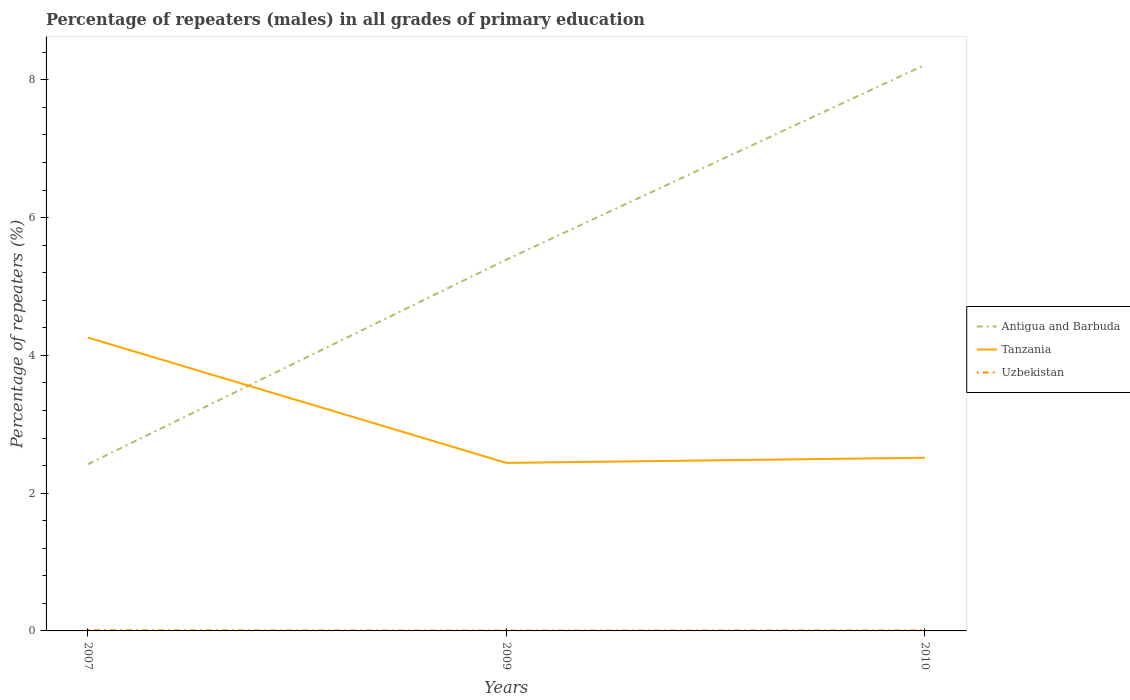Does the line corresponding to Antigua and Barbuda intersect with the line corresponding to Uzbekistan?
Your response must be concise. No. Across all years, what is the maximum percentage of repeaters (males) in Tanzania?
Give a very brief answer. 2.44. In which year was the percentage of repeaters (males) in Tanzania maximum?
Provide a succinct answer. 2009. What is the total percentage of repeaters (males) in Tanzania in the graph?
Offer a very short reply. 1.82. What is the difference between the highest and the second highest percentage of repeaters (males) in Tanzania?
Your response must be concise. 1.82. How many lines are there?
Make the answer very short. 3. How many years are there in the graph?
Your answer should be very brief. 3. What is the difference between two consecutive major ticks on the Y-axis?
Provide a succinct answer. 2. Does the graph contain grids?
Your answer should be very brief. No. How many legend labels are there?
Make the answer very short. 3. What is the title of the graph?
Give a very brief answer. Percentage of repeaters (males) in all grades of primary education. Does "Portugal" appear as one of the legend labels in the graph?
Give a very brief answer. No. What is the label or title of the X-axis?
Make the answer very short. Years. What is the label or title of the Y-axis?
Your answer should be compact. Percentage of repeaters (%). What is the Percentage of repeaters (%) in Antigua and Barbuda in 2007?
Your response must be concise. 2.42. What is the Percentage of repeaters (%) in Tanzania in 2007?
Keep it short and to the point. 4.26. What is the Percentage of repeaters (%) of Uzbekistan in 2007?
Give a very brief answer. 0.01. What is the Percentage of repeaters (%) of Antigua and Barbuda in 2009?
Offer a terse response. 5.39. What is the Percentage of repeaters (%) of Tanzania in 2009?
Make the answer very short. 2.44. What is the Percentage of repeaters (%) in Uzbekistan in 2009?
Ensure brevity in your answer.  0.01. What is the Percentage of repeaters (%) of Antigua and Barbuda in 2010?
Your answer should be very brief. 8.22. What is the Percentage of repeaters (%) in Tanzania in 2010?
Your answer should be compact. 2.51. What is the Percentage of repeaters (%) in Uzbekistan in 2010?
Provide a short and direct response. 0.01. Across all years, what is the maximum Percentage of repeaters (%) in Antigua and Barbuda?
Keep it short and to the point. 8.22. Across all years, what is the maximum Percentage of repeaters (%) of Tanzania?
Provide a succinct answer. 4.26. Across all years, what is the maximum Percentage of repeaters (%) of Uzbekistan?
Keep it short and to the point. 0.01. Across all years, what is the minimum Percentage of repeaters (%) of Antigua and Barbuda?
Make the answer very short. 2.42. Across all years, what is the minimum Percentage of repeaters (%) in Tanzania?
Keep it short and to the point. 2.44. Across all years, what is the minimum Percentage of repeaters (%) in Uzbekistan?
Offer a terse response. 0.01. What is the total Percentage of repeaters (%) in Antigua and Barbuda in the graph?
Ensure brevity in your answer.  16.03. What is the total Percentage of repeaters (%) in Tanzania in the graph?
Your response must be concise. 9.21. What is the total Percentage of repeaters (%) in Uzbekistan in the graph?
Provide a short and direct response. 0.02. What is the difference between the Percentage of repeaters (%) of Antigua and Barbuda in 2007 and that in 2009?
Offer a very short reply. -2.97. What is the difference between the Percentage of repeaters (%) of Tanzania in 2007 and that in 2009?
Your response must be concise. 1.82. What is the difference between the Percentage of repeaters (%) of Uzbekistan in 2007 and that in 2009?
Make the answer very short. 0.01. What is the difference between the Percentage of repeaters (%) of Antigua and Barbuda in 2007 and that in 2010?
Give a very brief answer. -5.8. What is the difference between the Percentage of repeaters (%) in Tanzania in 2007 and that in 2010?
Provide a succinct answer. 1.75. What is the difference between the Percentage of repeaters (%) in Uzbekistan in 2007 and that in 2010?
Your answer should be very brief. 0. What is the difference between the Percentage of repeaters (%) in Antigua and Barbuda in 2009 and that in 2010?
Keep it short and to the point. -2.83. What is the difference between the Percentage of repeaters (%) of Tanzania in 2009 and that in 2010?
Your answer should be very brief. -0.07. What is the difference between the Percentage of repeaters (%) in Uzbekistan in 2009 and that in 2010?
Your answer should be compact. -0. What is the difference between the Percentage of repeaters (%) in Antigua and Barbuda in 2007 and the Percentage of repeaters (%) in Tanzania in 2009?
Offer a very short reply. -0.02. What is the difference between the Percentage of repeaters (%) of Antigua and Barbuda in 2007 and the Percentage of repeaters (%) of Uzbekistan in 2009?
Offer a very short reply. 2.41. What is the difference between the Percentage of repeaters (%) of Tanzania in 2007 and the Percentage of repeaters (%) of Uzbekistan in 2009?
Offer a very short reply. 4.25. What is the difference between the Percentage of repeaters (%) in Antigua and Barbuda in 2007 and the Percentage of repeaters (%) in Tanzania in 2010?
Provide a succinct answer. -0.09. What is the difference between the Percentage of repeaters (%) of Antigua and Barbuda in 2007 and the Percentage of repeaters (%) of Uzbekistan in 2010?
Your response must be concise. 2.41. What is the difference between the Percentage of repeaters (%) in Tanzania in 2007 and the Percentage of repeaters (%) in Uzbekistan in 2010?
Offer a terse response. 4.25. What is the difference between the Percentage of repeaters (%) of Antigua and Barbuda in 2009 and the Percentage of repeaters (%) of Tanzania in 2010?
Provide a succinct answer. 2.88. What is the difference between the Percentage of repeaters (%) of Antigua and Barbuda in 2009 and the Percentage of repeaters (%) of Uzbekistan in 2010?
Your answer should be very brief. 5.38. What is the difference between the Percentage of repeaters (%) of Tanzania in 2009 and the Percentage of repeaters (%) of Uzbekistan in 2010?
Provide a short and direct response. 2.43. What is the average Percentage of repeaters (%) of Antigua and Barbuda per year?
Make the answer very short. 5.34. What is the average Percentage of repeaters (%) in Tanzania per year?
Offer a very short reply. 3.07. What is the average Percentage of repeaters (%) of Uzbekistan per year?
Give a very brief answer. 0.01. In the year 2007, what is the difference between the Percentage of repeaters (%) in Antigua and Barbuda and Percentage of repeaters (%) in Tanzania?
Your response must be concise. -1.84. In the year 2007, what is the difference between the Percentage of repeaters (%) in Antigua and Barbuda and Percentage of repeaters (%) in Uzbekistan?
Offer a terse response. 2.41. In the year 2007, what is the difference between the Percentage of repeaters (%) of Tanzania and Percentage of repeaters (%) of Uzbekistan?
Keep it short and to the point. 4.25. In the year 2009, what is the difference between the Percentage of repeaters (%) of Antigua and Barbuda and Percentage of repeaters (%) of Tanzania?
Your response must be concise. 2.95. In the year 2009, what is the difference between the Percentage of repeaters (%) in Antigua and Barbuda and Percentage of repeaters (%) in Uzbekistan?
Give a very brief answer. 5.38. In the year 2009, what is the difference between the Percentage of repeaters (%) of Tanzania and Percentage of repeaters (%) of Uzbekistan?
Provide a short and direct response. 2.43. In the year 2010, what is the difference between the Percentage of repeaters (%) in Antigua and Barbuda and Percentage of repeaters (%) in Tanzania?
Provide a short and direct response. 5.7. In the year 2010, what is the difference between the Percentage of repeaters (%) in Antigua and Barbuda and Percentage of repeaters (%) in Uzbekistan?
Ensure brevity in your answer.  8.21. In the year 2010, what is the difference between the Percentage of repeaters (%) of Tanzania and Percentage of repeaters (%) of Uzbekistan?
Make the answer very short. 2.5. What is the ratio of the Percentage of repeaters (%) of Antigua and Barbuda in 2007 to that in 2009?
Your answer should be compact. 0.45. What is the ratio of the Percentage of repeaters (%) of Tanzania in 2007 to that in 2009?
Ensure brevity in your answer.  1.75. What is the ratio of the Percentage of repeaters (%) of Uzbekistan in 2007 to that in 2009?
Offer a very short reply. 2.2. What is the ratio of the Percentage of repeaters (%) of Antigua and Barbuda in 2007 to that in 2010?
Provide a short and direct response. 0.29. What is the ratio of the Percentage of repeaters (%) in Tanzania in 2007 to that in 2010?
Your answer should be very brief. 1.69. What is the ratio of the Percentage of repeaters (%) in Uzbekistan in 2007 to that in 2010?
Provide a short and direct response. 1.3. What is the ratio of the Percentage of repeaters (%) of Antigua and Barbuda in 2009 to that in 2010?
Offer a very short reply. 0.66. What is the ratio of the Percentage of repeaters (%) in Tanzania in 2009 to that in 2010?
Offer a very short reply. 0.97. What is the ratio of the Percentage of repeaters (%) in Uzbekistan in 2009 to that in 2010?
Make the answer very short. 0.59. What is the difference between the highest and the second highest Percentage of repeaters (%) in Antigua and Barbuda?
Your answer should be compact. 2.83. What is the difference between the highest and the second highest Percentage of repeaters (%) of Tanzania?
Offer a very short reply. 1.75. What is the difference between the highest and the second highest Percentage of repeaters (%) in Uzbekistan?
Your answer should be compact. 0. What is the difference between the highest and the lowest Percentage of repeaters (%) in Antigua and Barbuda?
Your answer should be compact. 5.8. What is the difference between the highest and the lowest Percentage of repeaters (%) in Tanzania?
Offer a terse response. 1.82. What is the difference between the highest and the lowest Percentage of repeaters (%) in Uzbekistan?
Make the answer very short. 0.01. 